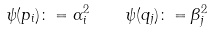Convert formula to latex. <formula><loc_0><loc_0><loc_500><loc_500>\psi ( p _ { i } ) \colon = \alpha _ { i } ^ { 2 } \quad \psi ( q _ { j } ) \colon = \beta _ { j } ^ { 2 }</formula> 